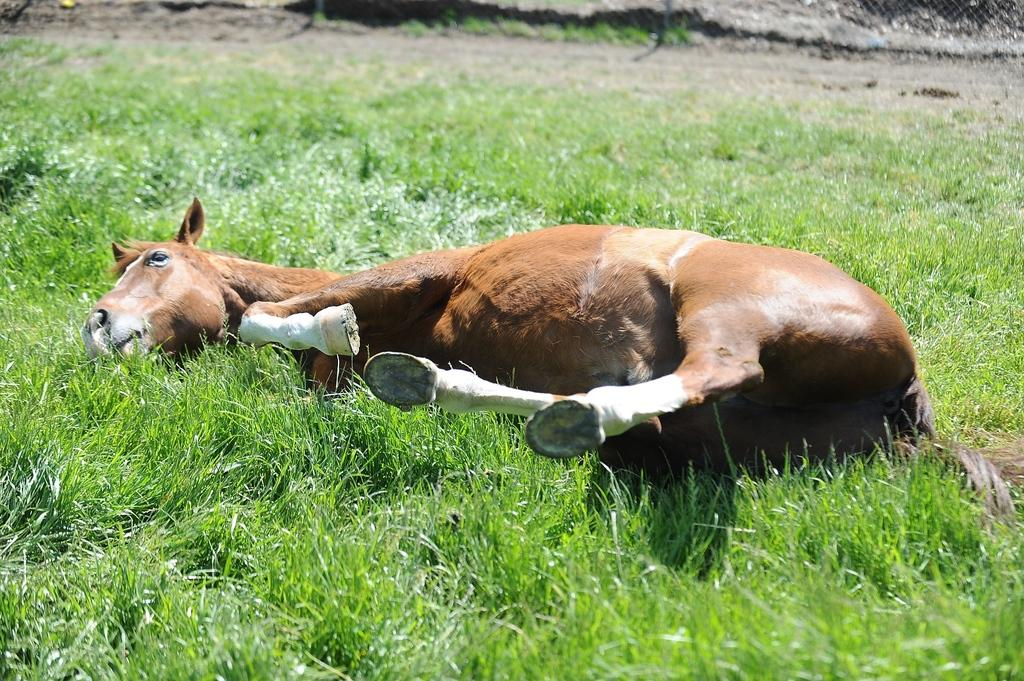What type of vegetation is present on the ground in the image? There is grass on the ground in the image. Where is the grass located in relation to the rest of the image? The grass is in the front of the image. What animal can be seen in the image? There is a horse in the image. What is the position of the horse in the image? The horse is laying on the ground. How is the horse positioned within the image? The horse is in the center of the image. What type of potato is being used to tell a story in the image? There is no potato or storytelling activity present in the image. How does the horse roll in the image? The horse is laying on the ground and not rolling in the image. 